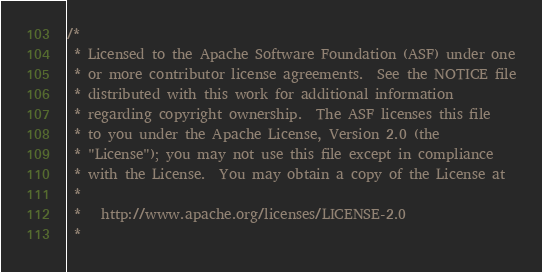<code> <loc_0><loc_0><loc_500><loc_500><_C++_>/*
 * Licensed to the Apache Software Foundation (ASF) under one
 * or more contributor license agreements.  See the NOTICE file
 * distributed with this work for additional information
 * regarding copyright ownership.  The ASF licenses this file
 * to you under the Apache License, Version 2.0 (the
 * "License"); you may not use this file except in compliance
 * with the License.  You may obtain a copy of the License at
 *
 *   http://www.apache.org/licenses/LICENSE-2.0
 *</code> 